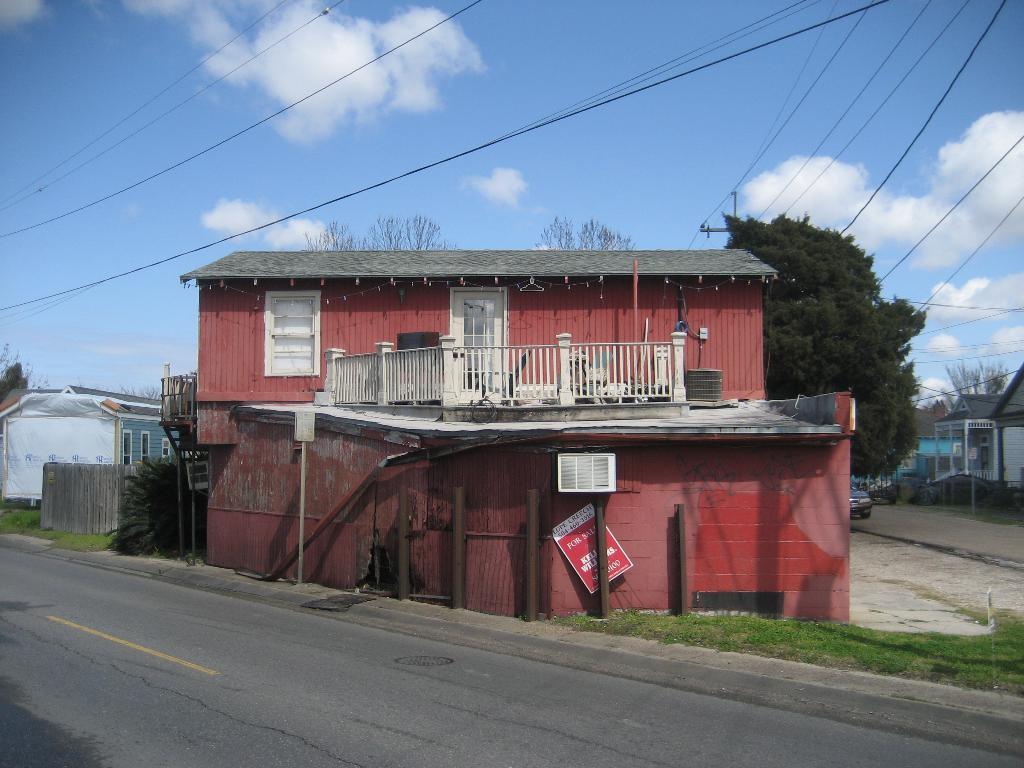Can you describe this image briefly? In the image there is a building and around that there are few houses and trees, on the right side there is a vehicle parked beside the road. 